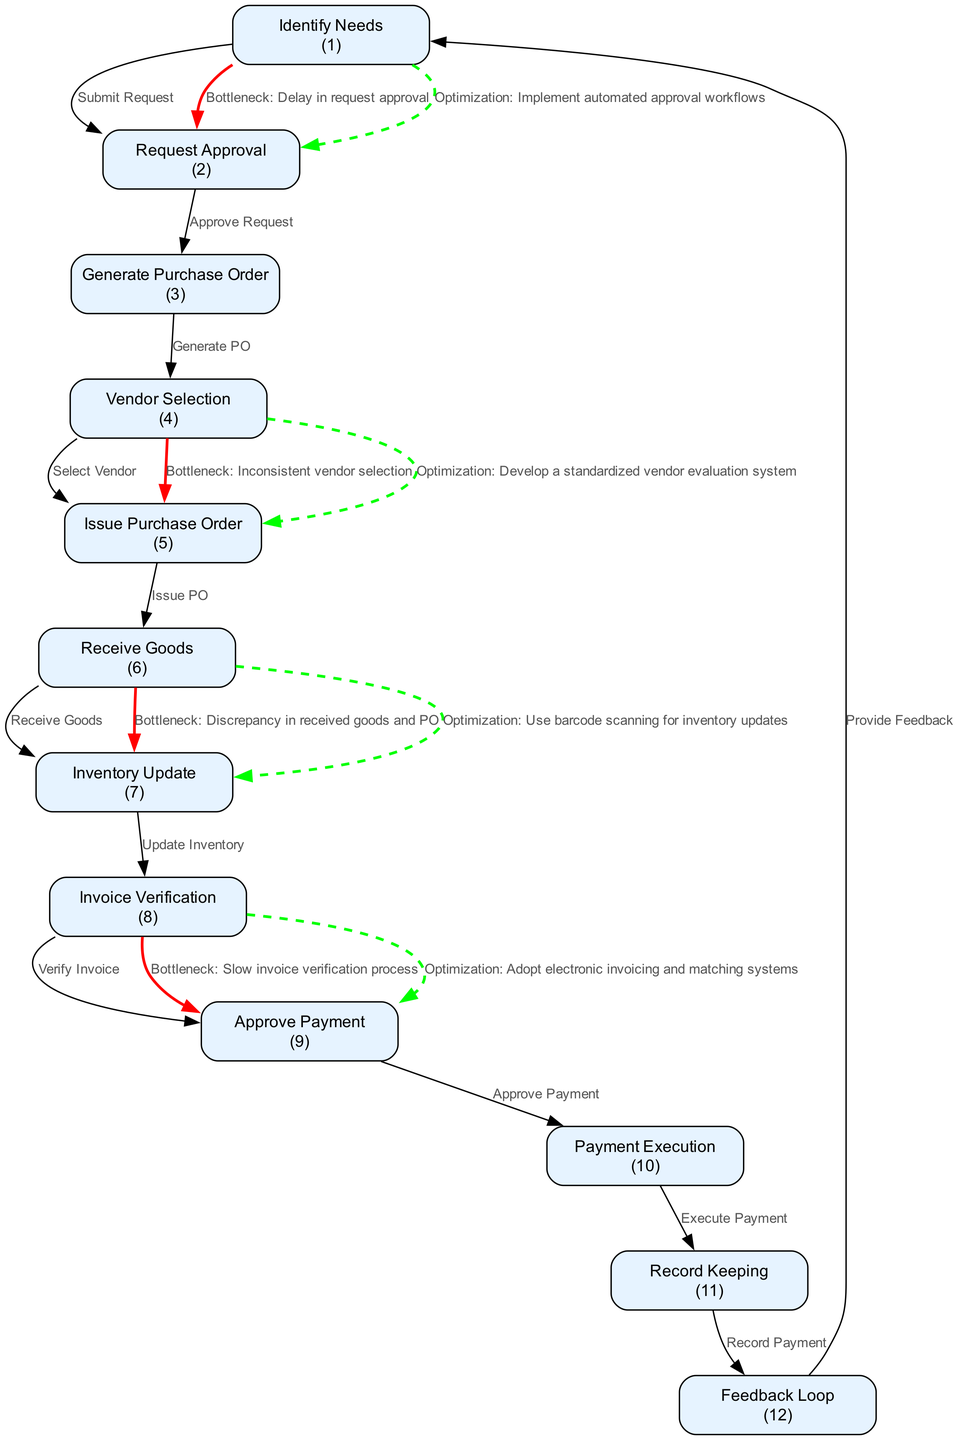What is the first step in the procurement to payment cycle? The first step is "Identify Needs," where the department identifies and requests needed medical supplies.
Answer: Identify Needs How many bottlenecks are highlighted in the diagram? The diagram highlights four bottlenecks that can potentially slow down the procurement to payment process.
Answer: Four What type of workflow is represented by the arrows in the diagram? The arrows indicate a directed workflow that shows the progression from one step to the next in the procurement to payment cycle.
Answer: Directed workflow Which node is related to the verification of invoices? The node "Invoice Verification" corresponds to the step where vendor invoices are checked against purchase orders and received goods.
Answer: Invoice Verification What optimization is suggested for the issue of slow invoice verification? The diagram recommends adopting electronic invoicing and matching systems to improve the speed of invoice verification.
Answer: Adopt electronic invoicing and matching systems Which step comes after "Receive Goods"? The step that follows "Receive Goods" is "Inventory Update," where the inventory management system is updated with the received goods.
Answer: Inventory Update What color indicates a bottleneck on the diagram? Red color is used to denote bottlenecks in the procurement to payment cycle within the diagram.
Answer: Red How does the diagram suggest speeding up the request approval process? The diagram suggests implementing automated approval workflows to streamline the request approval step.
Answer: Implement automated approval workflows What action is taken after "Approve Payment"? After "Approve Payment," the action taken is "Payment Execution," where the actual payment to the vendor is processed.
Answer: Payment Execution 